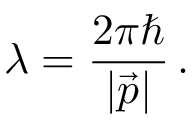Convert formula to latex. <formula><loc_0><loc_0><loc_500><loc_500>\lambda = \frac { 2 \pi } { | \vec { p } | } \, .</formula> 